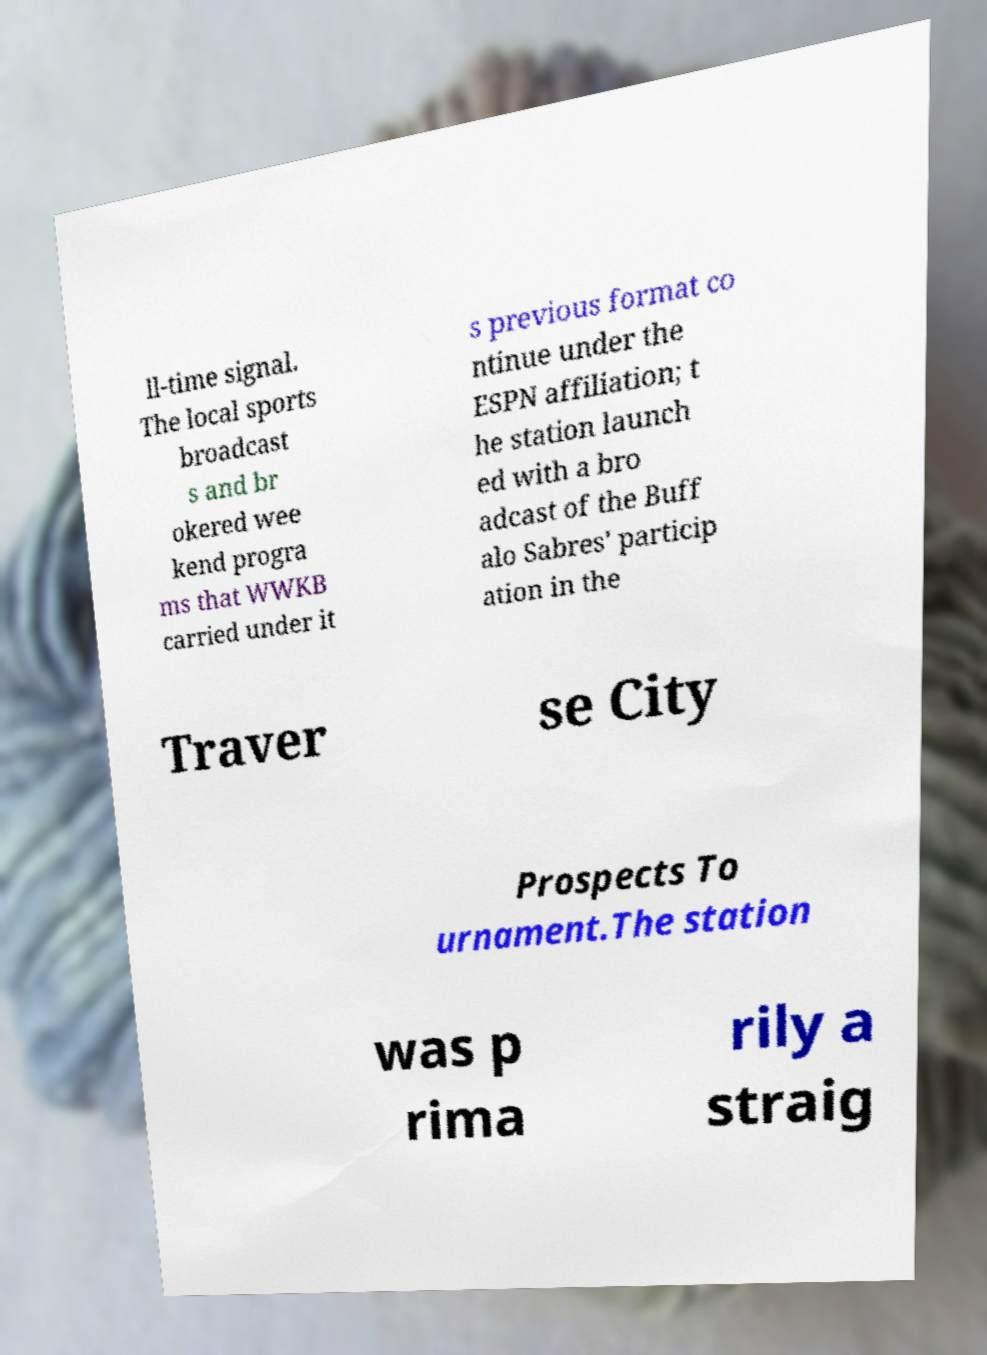Please identify and transcribe the text found in this image. ll-time signal. The local sports broadcast s and br okered wee kend progra ms that WWKB carried under it s previous format co ntinue under the ESPN affiliation; t he station launch ed with a bro adcast of the Buff alo Sabres' particip ation in the Traver se City Prospects To urnament.The station was p rima rily a straig 